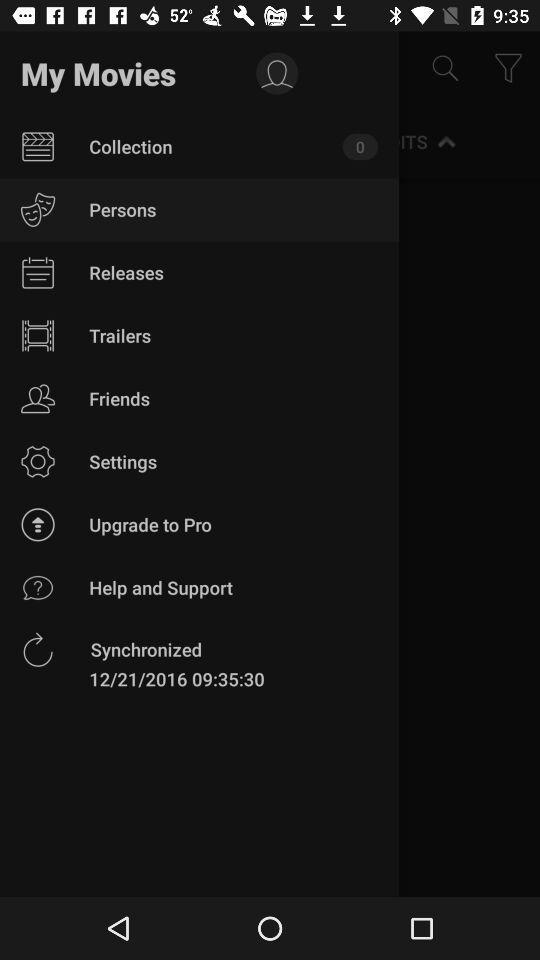How many items are there in the "Collection"? There are 0 items in the "Collection". 